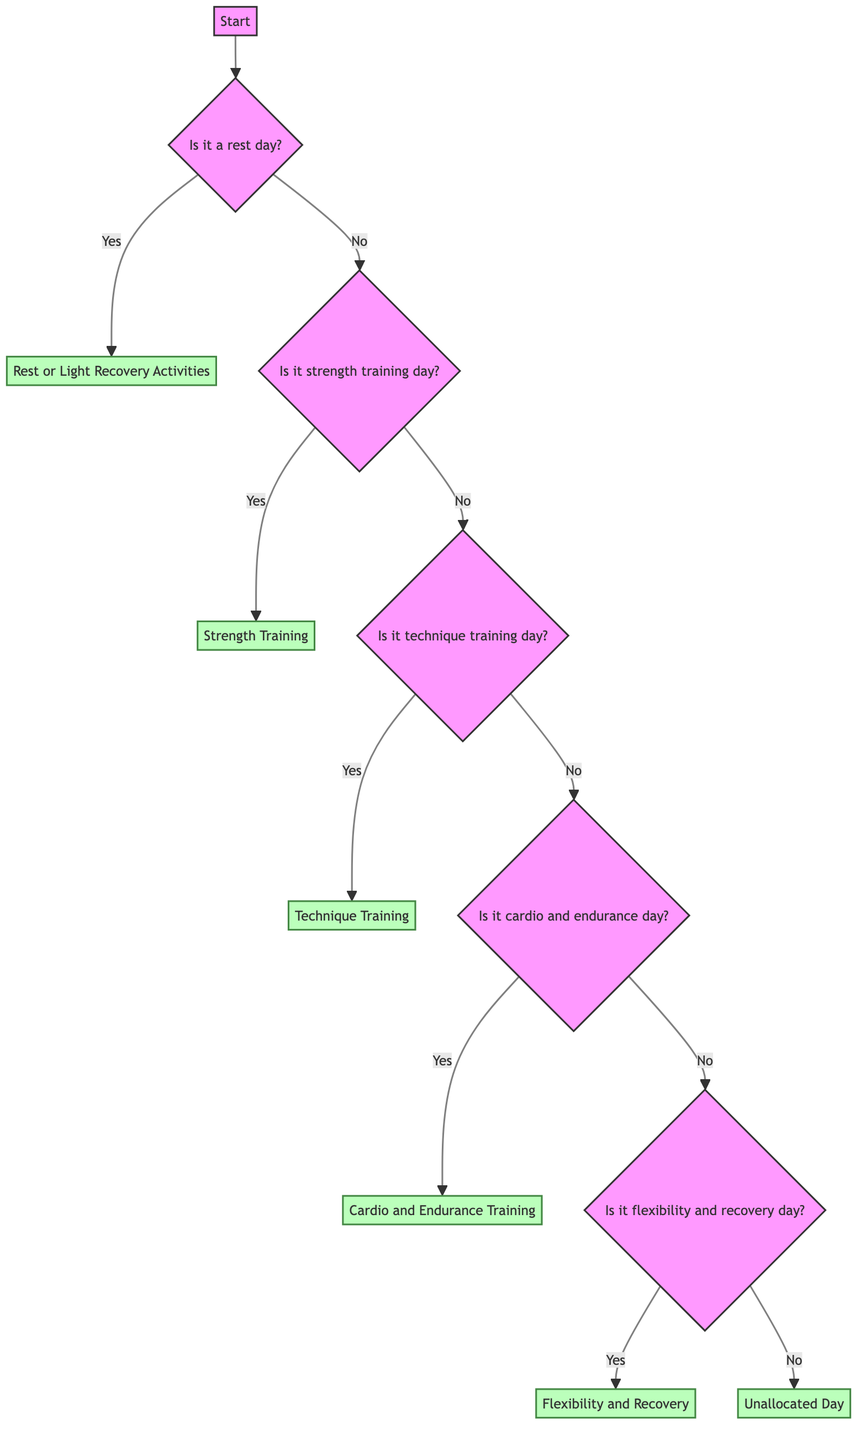Is the first question in the decision tree about rest days? The first question directed from the "Start" node is "Is it a rest day?" This indicates that the decision process begins by determining whether the day is a rest day or not.
Answer: Yes How many main decision branches are there after the "Is it a rest day?" question? From the "Is it a rest day?" question, there are two main branches: "Yes" (leading to rest activities) and "No" (leading to further questions about training types). Thus, this question has two branches.
Answer: 2 What is the plan if it is a strength training day? If it is determined that it is a strength training day, the plan is "Strength Training," where several details about exercises and repetitions follow.
Answer: Strength Training What activities are included in the flexibility and recovery day? For the flexibility and recovery day, the activities listed in the details include "Yoga, Static Stretching, Foam Rolling" and the specific areas emphasized are "Hamstrings, Quadriceps, Shoulders."
Answer: Yoga, Static Stretching, Foam Rolling If today is not a rest day, is it possible to have an unallocated day? Yes, if today is not classified under rest, strength, technique, cardio, or flexibility and recovery, it leads to an "Unallocated Day," suggesting consideration for rest or specific focus.
Answer: Yes What is the advice given for an unallocated day? The advice provided for an unallocated day is "Consider adding a rest or specific focus area for the long-term benefit of the athletes." This emphasizes the importance of planning even on such days.
Answer: Consider adding a rest or specific focus area for the long-term benefit How many types of training days are included in the decision tree? There are four types of training days considered in the tree: strength training day, technique training day, cardio and endurance day, and flexibility and recovery day. This adds to a total of four types.
Answer: 4 What specific exercises are mentioned under strength training? The specific exercises listed under strength training include "Deadlifts, Squats, Bench Press, Pull-Ups," which aim to improve strength across various muscle groups.
Answer: Deadlifts, Squats, Bench Press, Pull-Ups What does the tree suggest if it's a cardio and endurance day? On a cardio and endurance day, the decision tree suggests a plan that includes warm-up activities such as "Jogging, Dynamic Stretching" and training activities like "Sprints, Distance Running, Interval Training."
Answer: Cardio and Endurance Training 